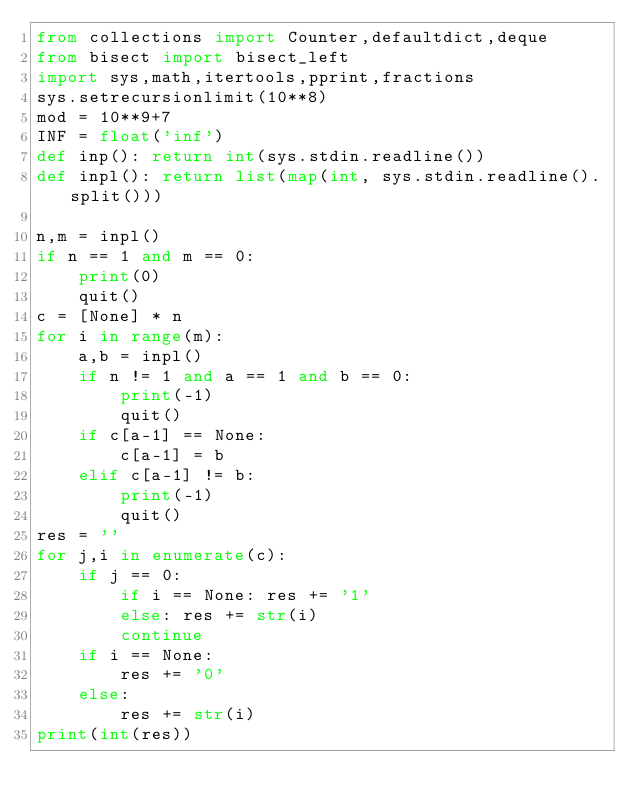Convert code to text. <code><loc_0><loc_0><loc_500><loc_500><_Python_>from collections import Counter,defaultdict,deque
from bisect import bisect_left
import sys,math,itertools,pprint,fractions
sys.setrecursionlimit(10**8)
mod = 10**9+7
INF = float('inf')
def inp(): return int(sys.stdin.readline())
def inpl(): return list(map(int, sys.stdin.readline().split()))

n,m = inpl()
if n == 1 and m == 0:
    print(0)
    quit()
c = [None] * n
for i in range(m):
    a,b = inpl()
    if n != 1 and a == 1 and b == 0:
        print(-1)
        quit()
    if c[a-1] == None:
        c[a-1] = b
    elif c[a-1] != b:
        print(-1)
        quit()
res = ''
for j,i in enumerate(c):
    if j == 0:
        if i == None: res += '1'
        else: res += str(i)
        continue
    if i == None:
        res += '0'
    else:
        res += str(i)
print(int(res))</code> 